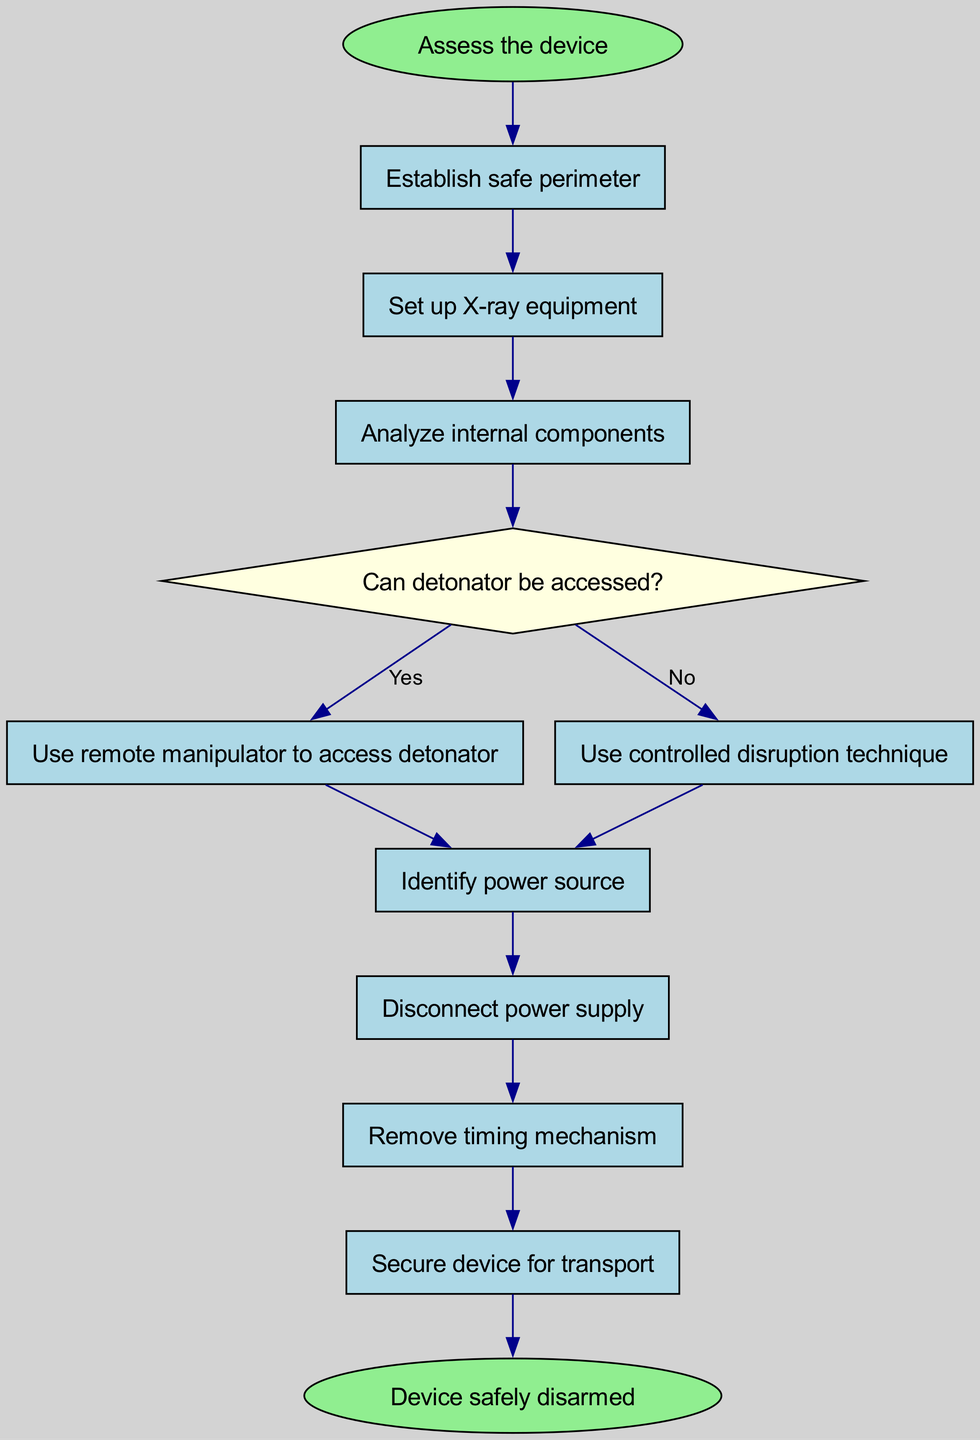What is the first step in the flow chart? The flow chart starts with the instruction to "Assess the device", which is the first action listed in the diagram.
Answer: Assess the device How many steps are there in the process before securing the device for transport? The flow chart includes a total of 7 steps before reaching the step of "Secure device for transport." Counting from "Establish safe perimeter" to "Remove timing mechanism" gives a total of 7 steps.
Answer: 7 What is the decision point in the flow chart? The flow chart includes one decision point: "Can detonator be accessed?" This is where a choice is made based on the accessibility of the detonator.
Answer: Can detonator be accessed? If the answer to the decision point is "Yes", what is the next action? If the answer to "Can detonator be accessed?" is "Yes", the next action is "Use remote manipulator to access detonator", as this action directly follows from the "Yes" path in the flow chart.
Answer: Use remote manipulator to access detonator What nodes immediately follow the "Disconnect power supply" step? Following the "Disconnect power supply" step, the immediate next node is "Remove timing mechanism". This indicates the direct step taken after the power supply is disconnected.
Answer: Remove timing mechanism What shape is used for decision nodes in the diagram? The decision nodes in the flow chart are represented as diamonds. This is a common practice in flow charts to distinguish decision points from other types of actions or steps.
Answer: Diamond How many edges are there leading from the decision node to the next steps? There are two edges leading from the decision node "Can detonator be accessed?", one for "Yes" leading to "Use remote manipulator to access detonator" and another for "No" leading to "Use controlled disruption technique".
Answer: 2 What is the final outcome indicated in the flow chart? The final outcome specified in the flow chart is "Device safely disarmed", which is listed as the end of the process in the diagram.
Answer: Device safely disarmed 